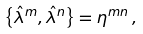<formula> <loc_0><loc_0><loc_500><loc_500>\left \{ \hat { \lambda } ^ { m } , \hat { \lambda } ^ { n } \right \} = \eta ^ { m n } \, ,</formula> 